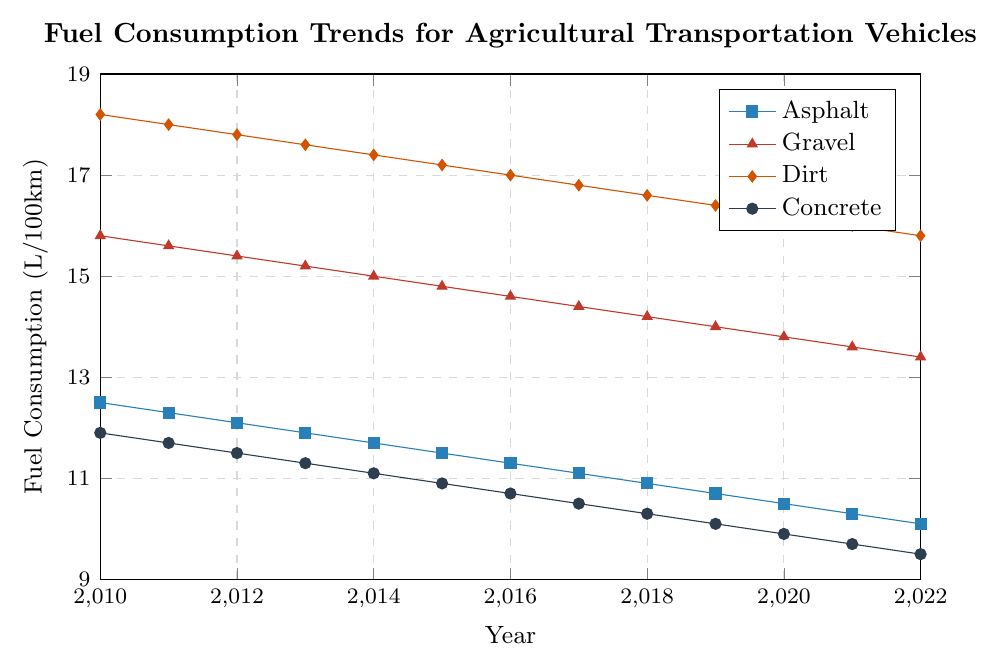What's the overall trend in fuel consumption for agricultural vehicles on asphalt roads from 2010 to 2022? The trend line for asphalt shows a consistent decrease in fuel consumption over the years from 12.5 L/100km in 2010 to 10.1 L/100km in 2022.
Answer: Decreasing Which road surface had the highest fuel consumption in 2022? Comparing the fuel consumption values for 2022: Asphalt (10.1), Gravel (13.4), Dirt (15.8), and Concrete (9.5), Dirt had the highest value.
Answer: Dirt Which road surface showed the least reduction in fuel consumption from 2010 to 2022? Calculate the reduction for each surface: Asphalt (12.5 - 10.1 = 2.4), Gravel (15.8 - 13.4 = 2.4), Dirt (18.2 - 15.8 = 2.4), Concrete (11.9 - 9.5 = 2.4). All surfaces show the same reduction of 2.4 L/100km.
Answer: Equal reduction In which year was the fuel consumption for vehicles on concrete roads the lowest? Observing the values for concrete roads, the lowest consumption was in 2022 at 9.5 L/100km.
Answer: 2022 What is the difference in fuel consumption between gravel and dirt roads in 2015? In 2015, the fuel consumption values for gravel and dirt roads are 14.8 and 17.2 L/100km respectively. The difference is 17.2 - 14.8.
Answer: 2.4 Between 2013 and 2018, which road surface exhibited the most consistent decline in fuel consumption? Check the yearly values for each road surface and calculate their differences: Asphalt (-1.0), Gravel (-1.0), Dirt (-1.0), Concrete (-1.0). All show the same consistent decline in values.
Answer: Equal decline Which road surface had a steeper decline in fuel consumption over the years: gravel or concrete? Compute the overall reduction: Gravel (15.8 - 13.4 = 2.4), Concrete (11.9 - 9.5 = 2.4). Both surfaces show the same decline.
Answer: Equal decline How does the fuel consumption on dirt roads in 2022 compare to that on concrete roads in 2010? Fuel consumption on dirt roads in 2022 is 15.8 L/100km and on concrete roads in 2010 is 11.9 L/100km. Dirt roads in 2022 have a higher value.
Answer: Dirt roads in 2022 higher What is the average fuel consumption of agricultural vehicles on asphalt roads over the period from 2010 to 2022? Sum the fuel consumption values for asphalt roads from 2010 to 2022 and then divide by the number of years (12.5+12.3+12.1+11.9+11.7+11.5+11.3+11.1+10.9+10.7+10.5+10.3+10.1)/13
Answer: 11.34 What was the fuel consumption trend for gravel roads from 2016 to 2020? The trend line for gravel roads from 2016 to 2020 shows a steady decrease in fuel consumption values from 14.6 (2016) to 13.8 (2020).
Answer: Decreasing 